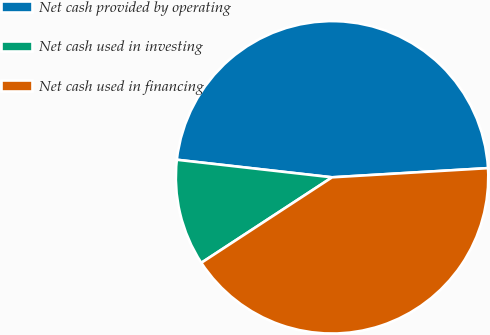Convert chart to OTSL. <chart><loc_0><loc_0><loc_500><loc_500><pie_chart><fcel>Net cash provided by operating<fcel>Net cash used in investing<fcel>Net cash used in financing<nl><fcel>47.27%<fcel>11.01%<fcel>41.72%<nl></chart> 